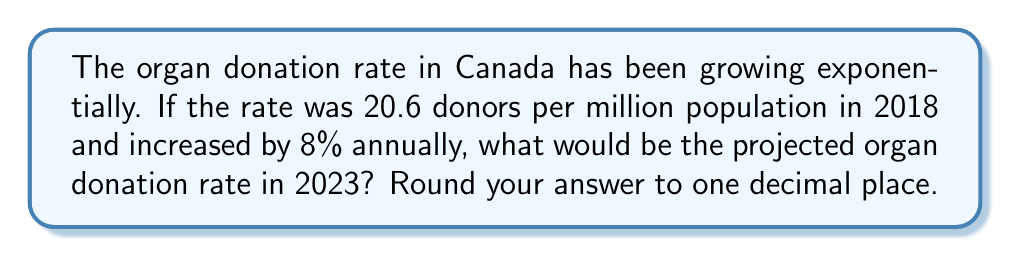Help me with this question. Let's approach this step-by-step:

1) We start with the initial rate in 2018: 20.6 donors per million population.

2) The growth rate is 8% annually, which means we multiply by 1.08 each year.

3) We need to calculate this for 5 years (2018 to 2023).

4) The formula for exponential growth is:
   $A = P(1 + r)^t$
   Where:
   $A$ = Final amount
   $P$ = Initial principal balance
   $r$ = Annual growth rate (as a decimal)
   $t$ = Number of years

5) Plugging in our values:
   $A = 20.6(1 + 0.08)^5$

6) Let's calculate:
   $A = 20.6(1.08)^5$
   $A = 20.6(1.4693280768)$
   $A = 30.2681583616$

7) Rounding to one decimal place:
   $A ≈ 30.3$

Therefore, the projected organ donation rate in 2023 would be approximately 30.3 donors per million population.
Answer: 30.3 donors per million population 